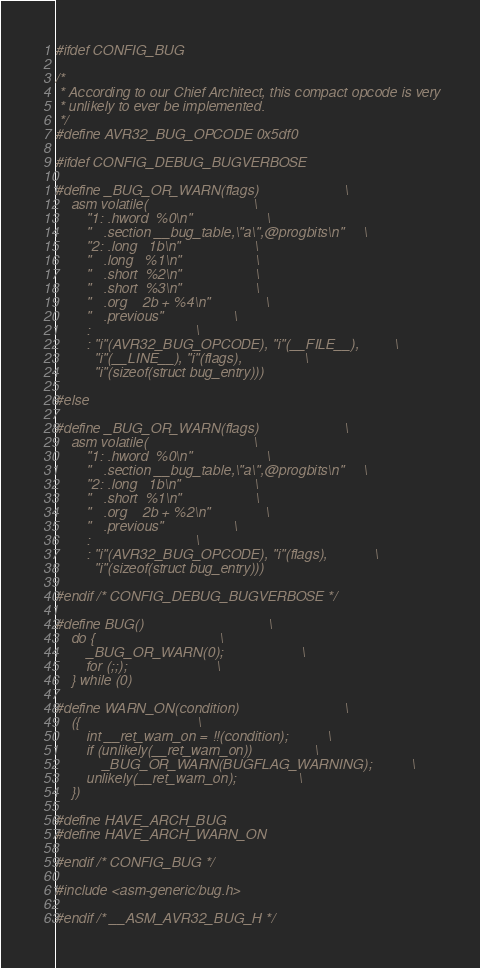Convert code to text. <code><loc_0><loc_0><loc_500><loc_500><_C_>
#ifdef CONFIG_BUG

/*
 * According to our Chief Architect, this compact opcode is very
 * unlikely to ever be implemented.
 */
#define AVR32_BUG_OPCODE	0x5df0

#ifdef CONFIG_DEBUG_BUGVERBOSE

#define _BUG_OR_WARN(flags)						\
	asm volatile(							\
		"1:	.hword	%0\n"					\
		"	.section __bug_table,\"a\",@progbits\n"		\
		"2:	.long	1b\n"					\
		"	.long	%1\n"					\
		"	.short	%2\n"					\
		"	.short	%3\n"					\
		"	.org	2b + %4\n"				\
		"	.previous"					\
		:							\
		: "i"(AVR32_BUG_OPCODE), "i"(__FILE__),			\
		  "i"(__LINE__), "i"(flags),				\
		  "i"(sizeof(struct bug_entry)))

#else

#define _BUG_OR_WARN(flags)						\
	asm volatile(							\
		"1:	.hword	%0\n"					\
		"	.section __bug_table,\"a\",@progbits\n"		\
		"2:	.long	1b\n"					\
		"	.short	%1\n"					\
		"	.org	2b + %2\n"				\
		"	.previous"					\
		:							\
		: "i"(AVR32_BUG_OPCODE), "i"(flags),			\
		  "i"(sizeof(struct bug_entry)))

#endif /* CONFIG_DEBUG_BUGVERBOSE */

#define BUG()								\
	do {								\
		_BUG_OR_WARN(0);					\
		for (;;);						\
	} while (0)

#define WARN_ON(condition)							\
	({								\
		int __ret_warn_on = !!(condition);			\
		if (unlikely(__ret_warn_on))				\
			_BUG_OR_WARN(BUGFLAG_WARNING);			\
		unlikely(__ret_warn_on);				\
	})

#define HAVE_ARCH_BUG
#define HAVE_ARCH_WARN_ON

#endif /* CONFIG_BUG */

#include <asm-generic/bug.h>

#endif /* __ASM_AVR32_BUG_H */
</code> 